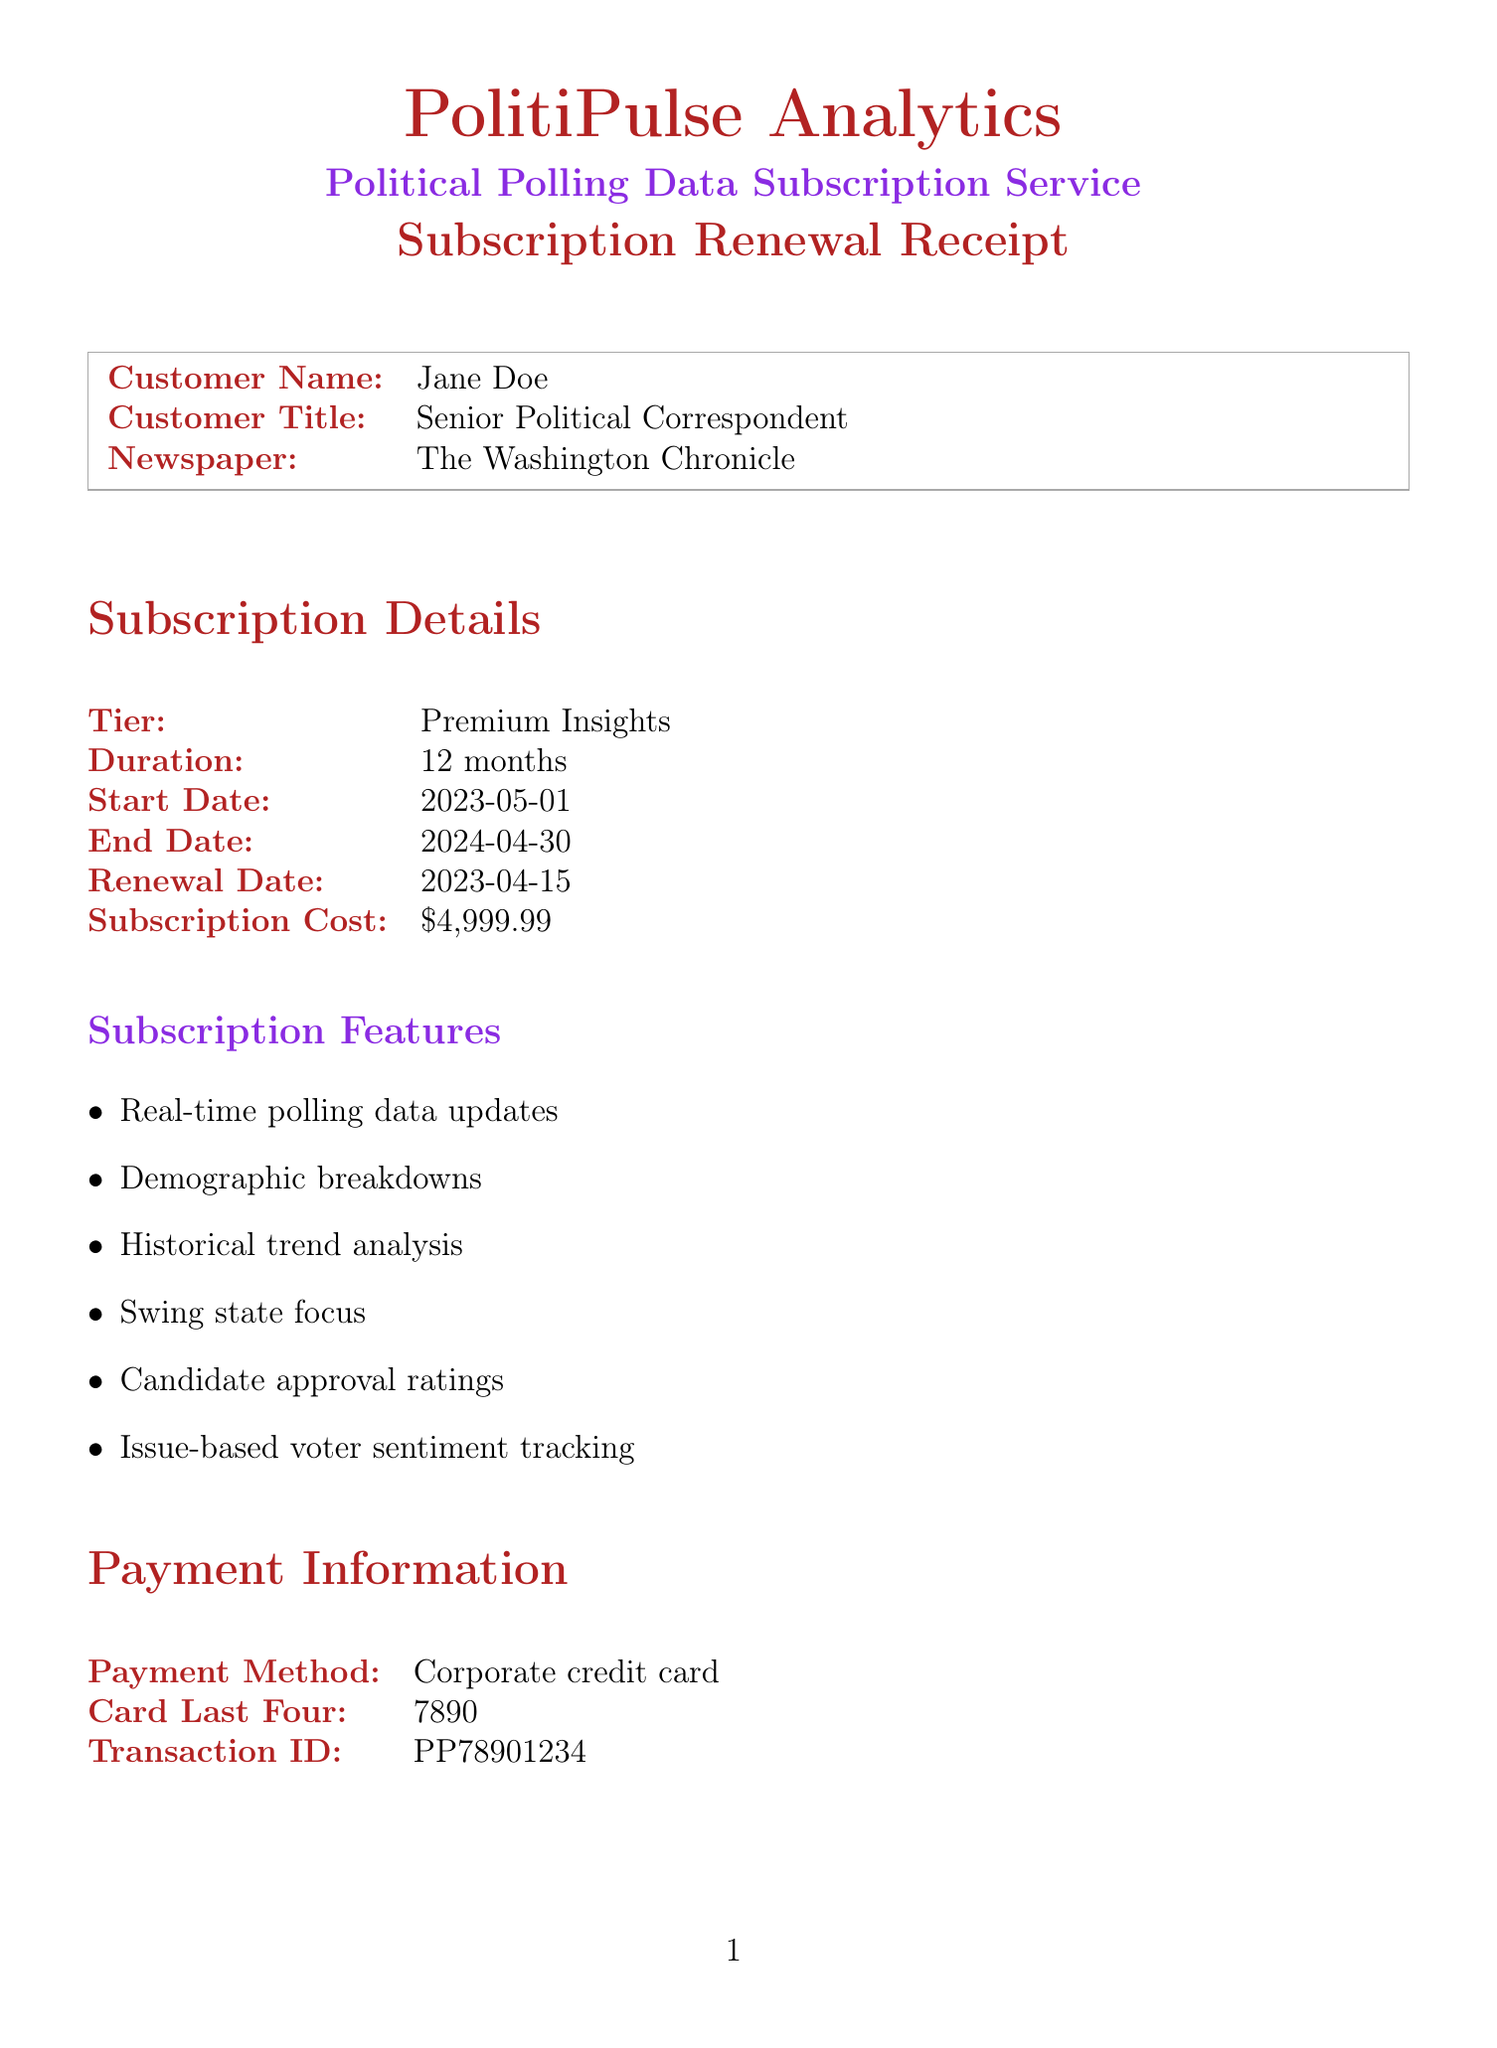What is the customer's name? The customer's name is specifically mentioned in the document, which is Jane Doe.
Answer: Jane Doe What is the subscription tier? The tier is listed under subscription details as Premium Insights.
Answer: Premium Insights When does the subscription end? The end date of the subscription is explicitly provided as 2024-04-30.
Answer: 2024-04-30 What is the total amount charged for the subscription? The total amount is calculated and stated as $5,799.97 in the receipt.
Answer: $5,799.97 What are the features included in the subscription? The features listed under Subscription Features detail the capabilities included, such as real-time polling data updates.
Answer: Real-time polling data updates Which upcoming election coverage is mentioned in the document? The upcoming elections listed are the 2023 Virginia state elections, 2024 U.S. Presidential primaries, and the 2024 U.S. Presidential election.
Answer: 2023 Virginia state elections What payment method was used? The payment method is mentioned as a Corporate credit card in the document.
Answer: Corporate credit card How much is the cost for customized battleground state reports? The cost for this additional service is explicitly mentioned as $499.99.
Answer: $499.99 Who is the account manager for this subscription? The document explicitly states that Michael Smith is the account manager.
Answer: Michael Smith 